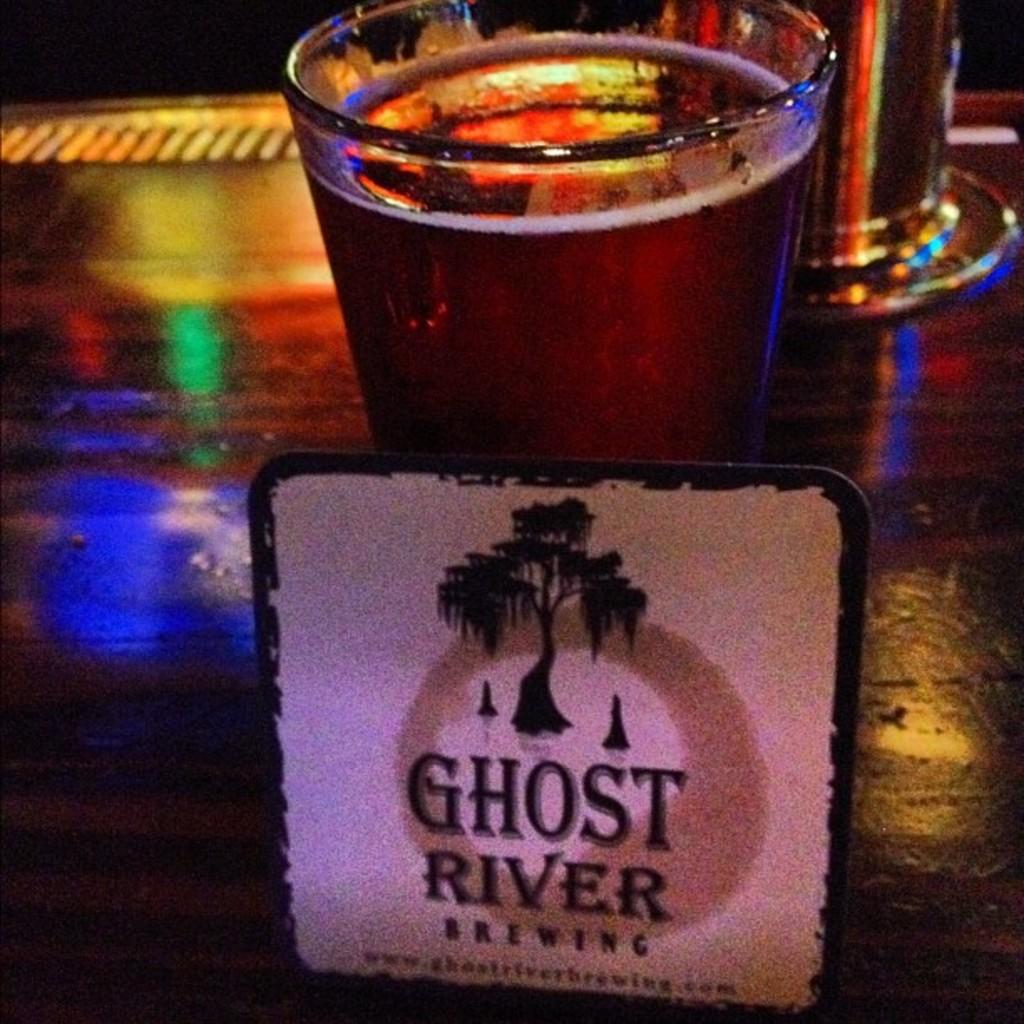What brewery is this?
Provide a succinct answer. Ghost river. 